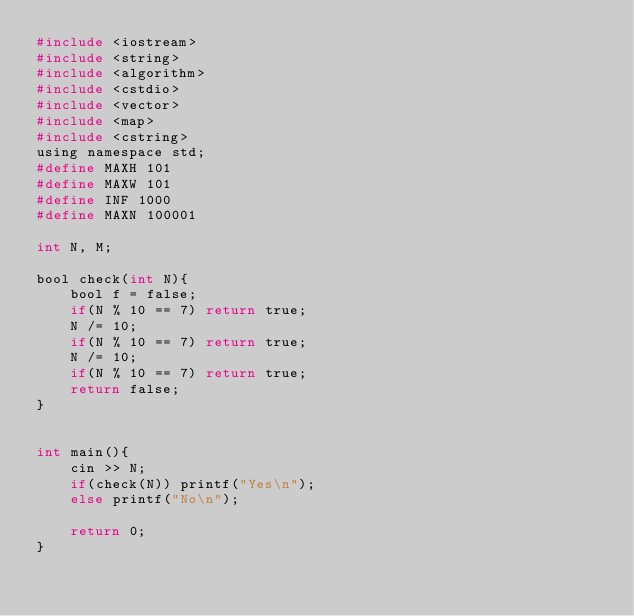<code> <loc_0><loc_0><loc_500><loc_500><_C_>#include <iostream>
#include <string>
#include <algorithm>
#include <cstdio>
#include <vector>
#include <map>
#include <cstring>
using namespace std;
#define MAXH 101
#define MAXW 101
#define INF 1000
#define MAXN 100001

int N, M;

bool check(int N){
    bool f = false;
    if(N % 10 == 7) return true;
    N /= 10;
    if(N % 10 == 7) return true;
    N /= 10;
    if(N % 10 == 7) return true;
    return false;
}


int main(){
    cin >> N;
    if(check(N)) printf("Yes\n");
    else printf("No\n");
    
    return 0;
}</code> 